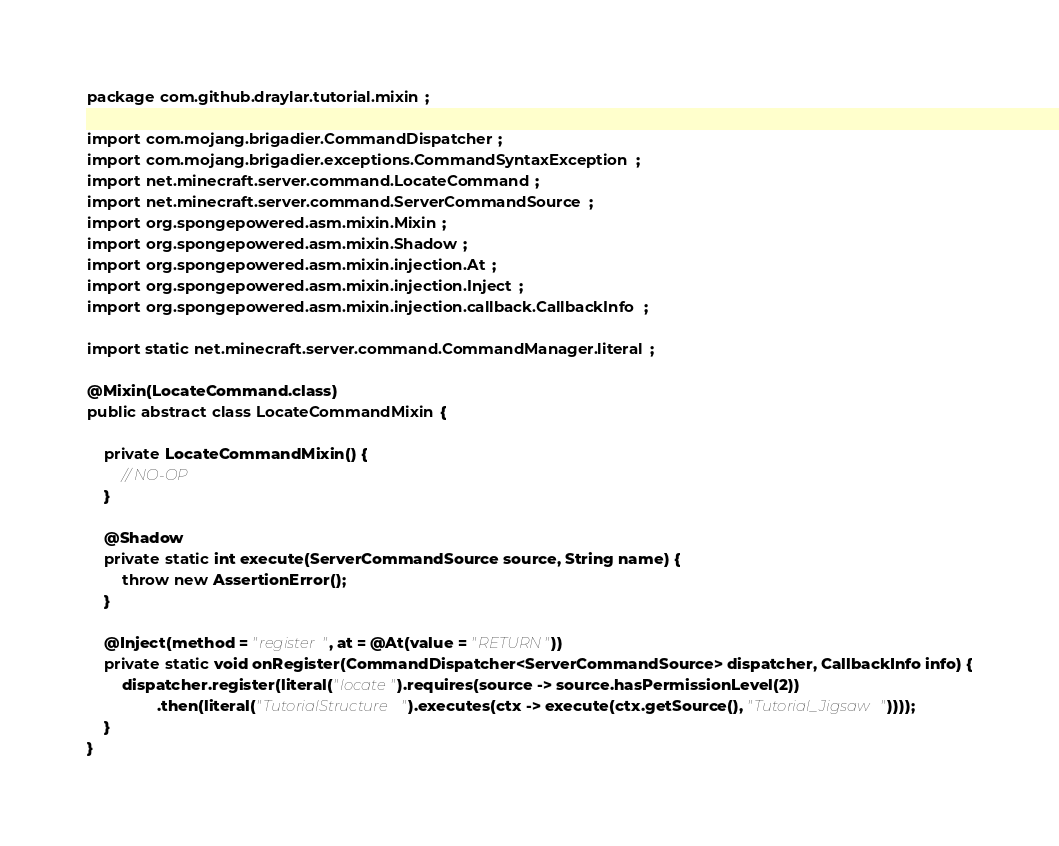Convert code to text. <code><loc_0><loc_0><loc_500><loc_500><_Java_>package com.github.draylar.tutorial.mixin;

import com.mojang.brigadier.CommandDispatcher;
import com.mojang.brigadier.exceptions.CommandSyntaxException;
import net.minecraft.server.command.LocateCommand;
import net.minecraft.server.command.ServerCommandSource;
import org.spongepowered.asm.mixin.Mixin;
import org.spongepowered.asm.mixin.Shadow;
import org.spongepowered.asm.mixin.injection.At;
import org.spongepowered.asm.mixin.injection.Inject;
import org.spongepowered.asm.mixin.injection.callback.CallbackInfo;

import static net.minecraft.server.command.CommandManager.literal;

@Mixin(LocateCommand.class)
public abstract class LocateCommandMixin {

    private LocateCommandMixin() {
        // NO-OP
    }

    @Shadow
    private static int execute(ServerCommandSource source, String name) {
        throw new AssertionError();
    }

    @Inject(method = "register", at = @At(value = "RETURN"))
    private static void onRegister(CommandDispatcher<ServerCommandSource> dispatcher, CallbackInfo info) {
        dispatcher.register(literal("locate").requires(source -> source.hasPermissionLevel(2))
                .then(literal("TutorialStructure").executes(ctx -> execute(ctx.getSource(), "Tutorial_Jigsaw"))));
    }
}</code> 